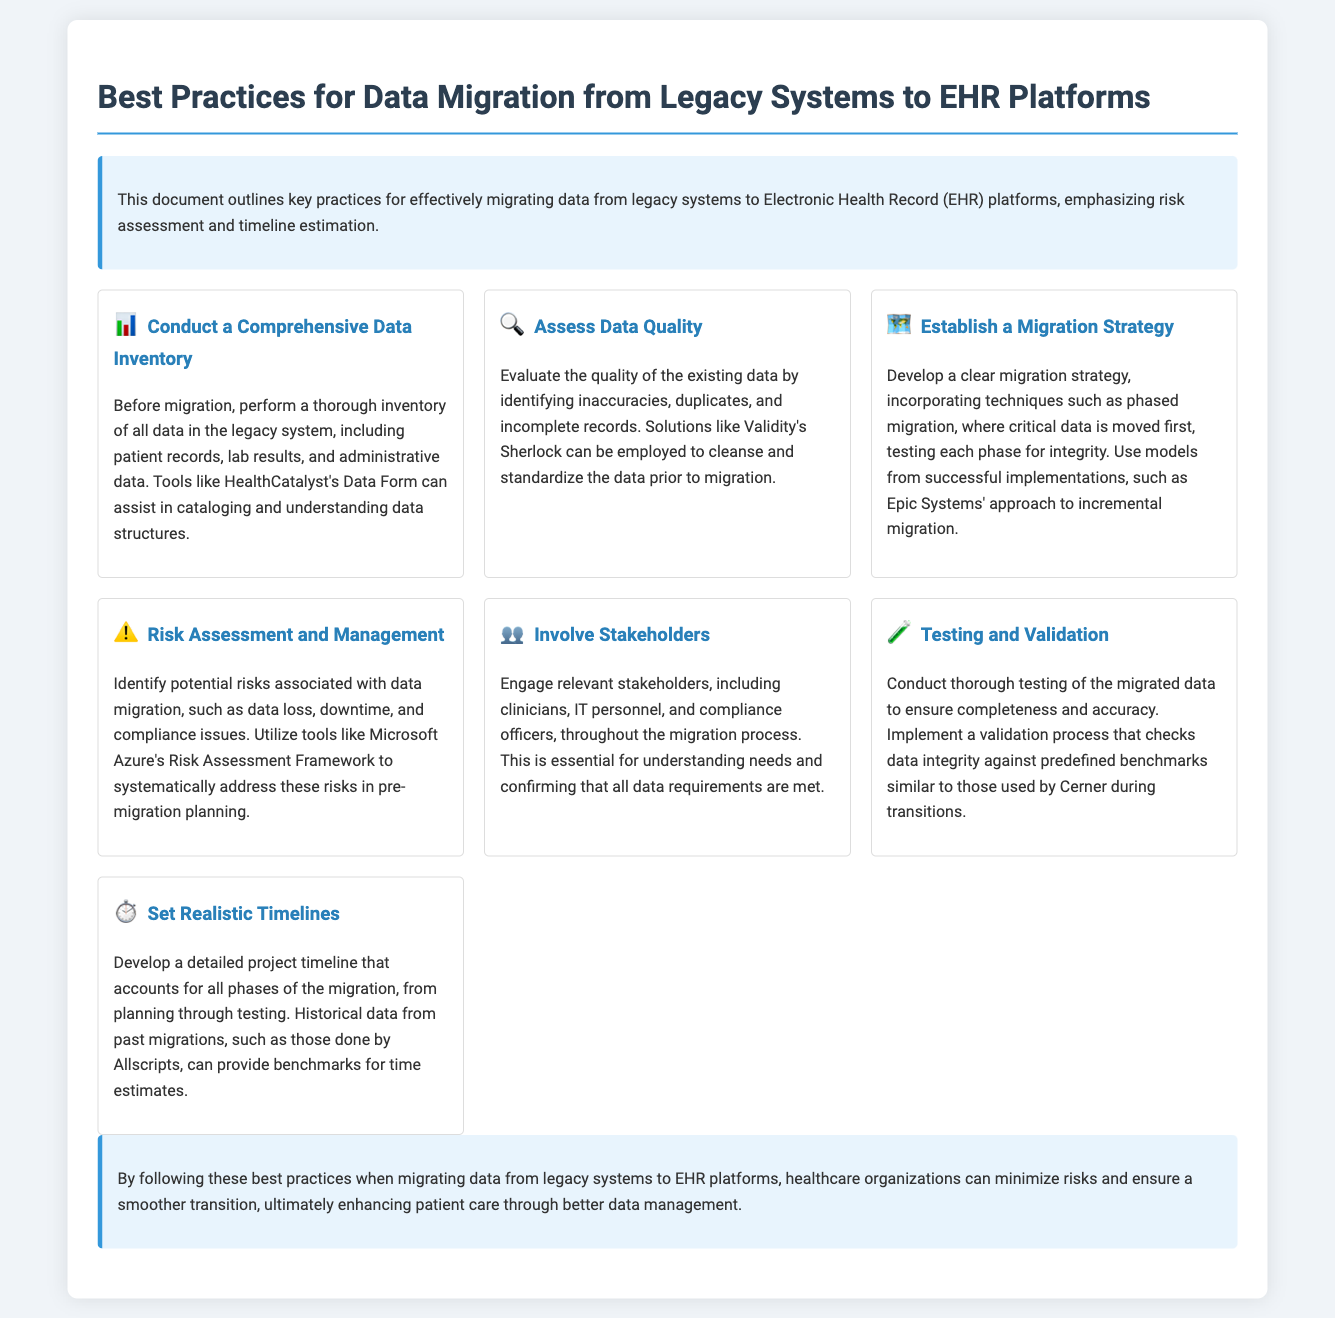What is the title of the document? The title of the document is presented prominently at the top, indicating the main subject of the content.
Answer: Best Practices for Data Migration from Legacy Systems to EHR Platforms What icon represents the migration strategy section? The document uses specific icons to visually represent different sections; the migration strategy has a unique icon.
Answer: 🗺️ Which tool is mentioned for conducting data quality assessments? A specific tool is referenced in the context of assessing data quality in the legacy system.
Answer: Validity's Sherlock What is the main purpose of involving stakeholders in the migration process? Involving stakeholders is crucial for ensuring all relevant needs are addressed during data migration.
Answer: Understanding needs What phase precedes the testing and validation of data during migration? The process includes several phases, and one logically occurs before testing and validation.
Answer: Migration How can organizations manage risks associated with data migration? The document discusses methodologies to identify and manage risks that may arise during the data migration process.
Answer: Utilize tools What is the recommended approach to set timelines for data migration? The document suggests methods to ensure timeline accuracy by drawing on historical data from other migrations.
Answer: Develop a detailed project timeline How are risks categorized in the migration process? The text mentions that several potential issues could arise, particularly during the planning phase of migration.
Answer: Data loss, downtime, compliance issues 